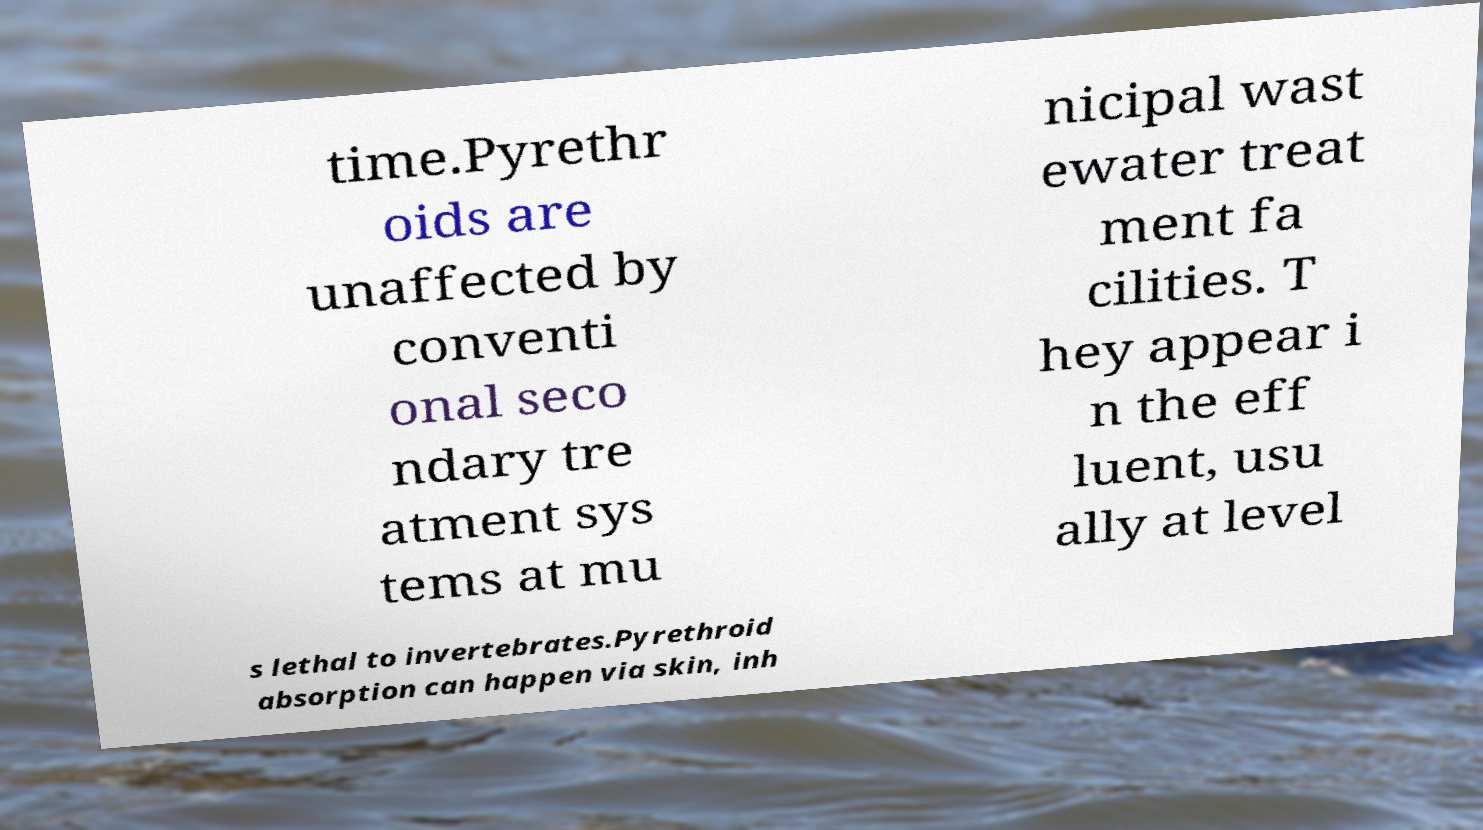What messages or text are displayed in this image? I need them in a readable, typed format. time.Pyrethr oids are unaffected by conventi onal seco ndary tre atment sys tems at mu nicipal wast ewater treat ment fa cilities. T hey appear i n the eff luent, usu ally at level s lethal to invertebrates.Pyrethroid absorption can happen via skin, inh 